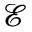Convert formula to latex. <formula><loc_0><loc_0><loc_500><loc_500>\mathcal { E }</formula> 